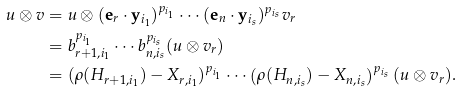<formula> <loc_0><loc_0><loc_500><loc_500>u \otimes v & = u \otimes ( \mathbf e _ { r } \cdot \mathbf y _ { i _ { 1 } } ) ^ { p _ { i _ { 1 } } } \cdots ( \mathbf e _ { n } \cdot \mathbf y _ { i _ { s } } ) ^ { p _ { i _ { s } } } v _ { r } \\ & = b _ { r + 1 , i _ { 1 } } ^ { p _ { i _ { 1 } } } \cdots b _ { n , i _ { s } } ^ { p _ { i _ { s } } } ( u \otimes v _ { r } ) \\ & = ( \rho ( H _ { r + 1 , i _ { 1 } } ) - X _ { r , i _ { 1 } } ) ^ { p _ { i _ { 1 } } } \cdots \left ( \rho ( H _ { n , i _ { s } } ) - X _ { n , i _ { s } } \right ) ^ { p _ { i _ { s } } } ( u \otimes v _ { r } ) .</formula> 